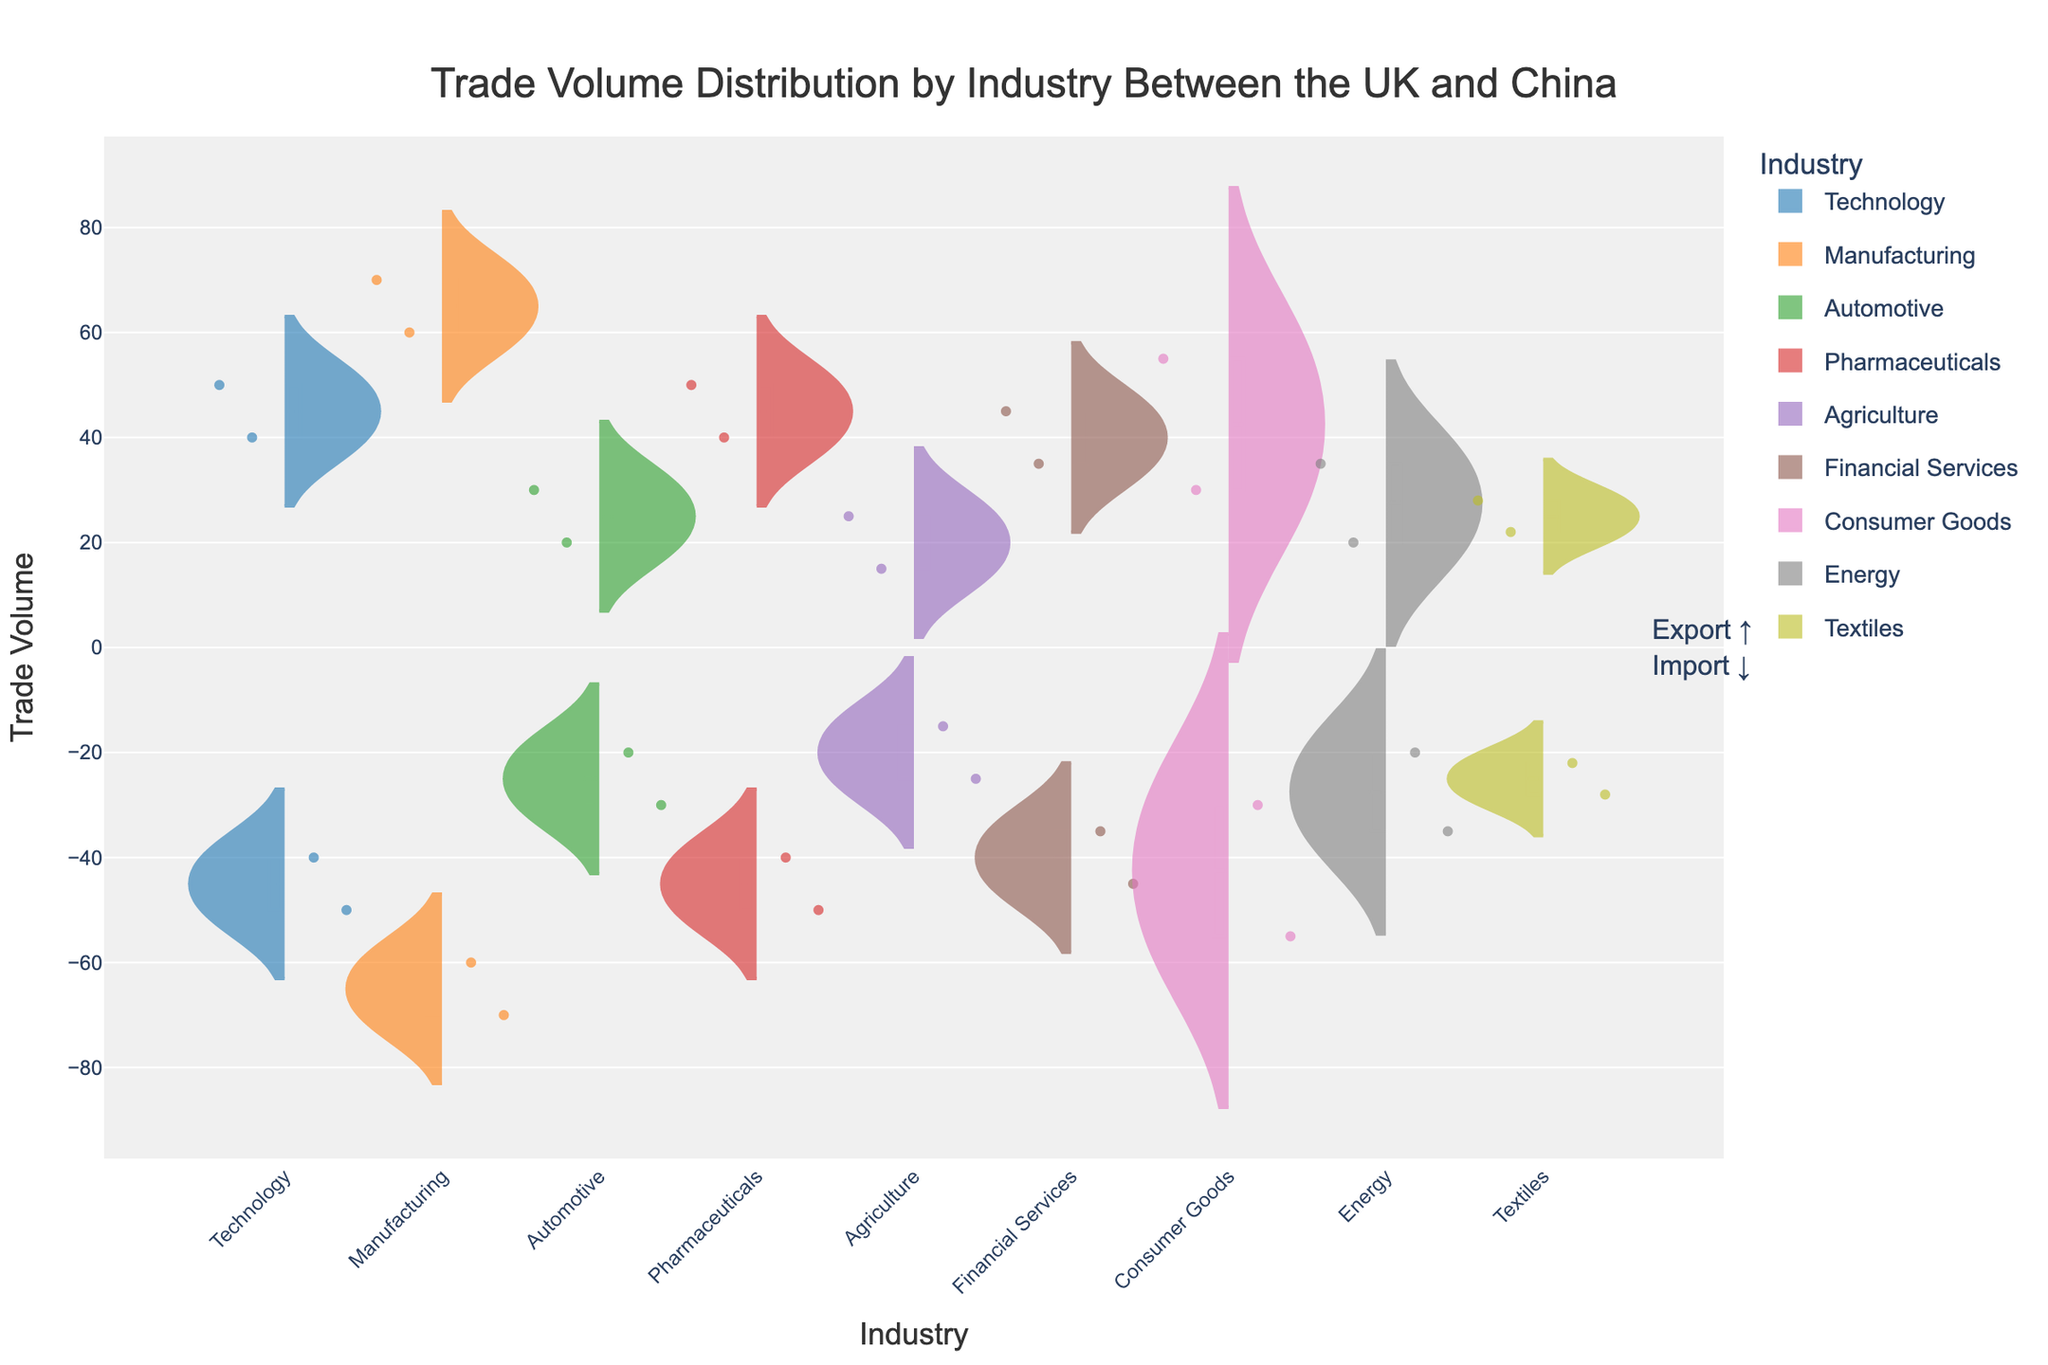What's the title of the plot? The title of the plot is displayed at the top center of the figure in larger font size. The title indicates the main topic or focus of the plot.
Answer: Trade Volume Distribution by Industry Between the UK and China What does the y-axis represent? The y-axis typically represents the measure or value that is being visualized in the plot. Here, it shows 'Trade Volume,' which indicates the volume of trade in different industries between the UK and China.
Answer: Trade Volume Which industry has a higher export volume: Technology or Manufacturing? The positive side of the violin plot for each industry shows the export volume. By comparing the heights of the positive distributions for Technology and Manufacturing, we see that Manufacturing has a higher peak at 70 compared to Technology at 50.
Answer: Manufacturing How many industries have a positive export trade volume greater than 50? By examining the distributions on the positive side for each industry and comparing their peaks, we see that Technology, Manufacturing, and Consumer Goods have export volumes greater than 50. This counts as three industries.
Answer: 3 What is the difference in export volume and import volume for Agriculture? The export and import volumes for Agriculture are represented on the positive and negative sides of the plot. Export volume for Agriculture is 25, and import volume is 15. The difference is calculated as 25 - 15.
Answer: 10 Which industry shows an equal volume for both export and import? For an industry to have equal export and import volumes, we look for identical heights on both the positive and negative sides of its violin plot. In this case, Textiles has an export volume of 28 and an import volume of 22, so there is no industry with equal volumes in the provided data.
Answer: None What can be inferred about the trade balance of Pharmaceuticals? By comparing the positive side (export) and negative side (import) for Pharmaceuticals, we see that the export volume is 40 and the import volume is 50. Since the import volume is higher than the export volume, it indicates a trade deficit in Pharmaceuticals.
Answer: Trade Deficit Which industry has the lowest trade volume, either export or import? By reviewing the lowest points on both sides of the violin plots, we see Agriculture’s import volume is the lowest at 15.
Answer: Agriculture (import) Between Consumer Goods and Financial Services, which one has a higher import volume? The negative side of the violin plots represents import volumes. Consumer Goods has an import volume of 30, and Financial Services has an import volume of 45. Therefore, Financial Services has a higher import volume.
Answer: Financial Services 